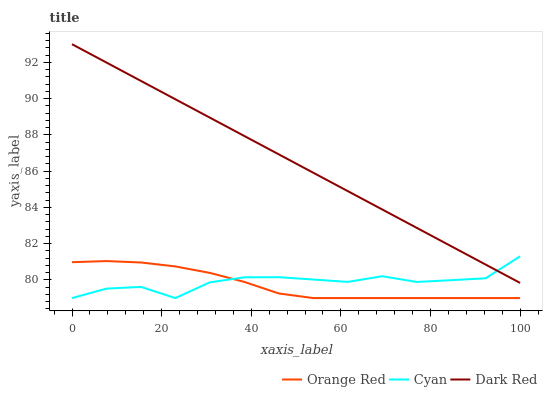Does Orange Red have the minimum area under the curve?
Answer yes or no. Yes. Does Dark Red have the maximum area under the curve?
Answer yes or no. Yes. Does Dark Red have the minimum area under the curve?
Answer yes or no. No. Does Orange Red have the maximum area under the curve?
Answer yes or no. No. Is Dark Red the smoothest?
Answer yes or no. Yes. Is Cyan the roughest?
Answer yes or no. Yes. Is Orange Red the smoothest?
Answer yes or no. No. Is Orange Red the roughest?
Answer yes or no. No. Does Cyan have the lowest value?
Answer yes or no. Yes. Does Dark Red have the lowest value?
Answer yes or no. No. Does Dark Red have the highest value?
Answer yes or no. Yes. Does Orange Red have the highest value?
Answer yes or no. No. Is Orange Red less than Dark Red?
Answer yes or no. Yes. Is Dark Red greater than Orange Red?
Answer yes or no. Yes. Does Dark Red intersect Cyan?
Answer yes or no. Yes. Is Dark Red less than Cyan?
Answer yes or no. No. Is Dark Red greater than Cyan?
Answer yes or no. No. Does Orange Red intersect Dark Red?
Answer yes or no. No. 